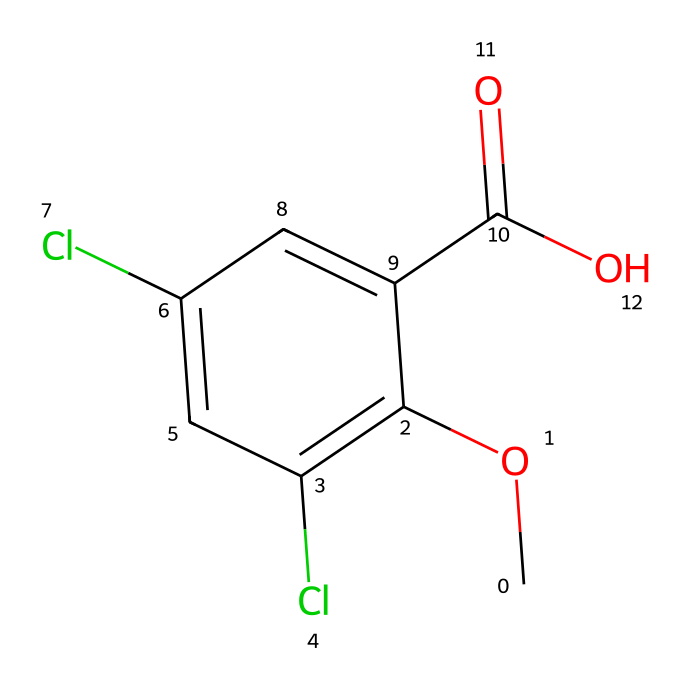What is the main functional group present in dicamba? The chemical has a carboxylic acid group, indicated by the -COOH moiety in its structure. This is typically represented by the "-C(=O)O" part in the SMILES notation.
Answer: carboxylic acid How many chlorine atoms are present in dicamba? By examining the structure, we see two chlorine atoms attached to the aromatic ring. In the SMILES, they are represented as "Cl" and appear twice.
Answer: 2 What is the primary use of dicamba? Dicamba is primarily used as a herbicide. Its purpose is to control broadleaf weeds and other unwanted vegetation in agricultural settings.
Answer: herbicide Which element in dicamba contributes to its electronegativity and stability? The presence of chlorine atoms increases the electronegativity of the molecule, which helps stabilize the overall structure by attracting electrons. Chlorine is known for having a high electronegativity.
Answer: chlorine What is the total number of carbon atoms in dicamba? The structure shows a total of seven carbon atoms, which can be counted from the aromatic and aliphatic parts of the molecule in the SMILES representation.
Answer: 7 How does the presence of the -COO group affect dicamba’s solubility? The carboxylic acid (-COOH) functional group enhances the solubility of dicamba in water compared to non-polar compounds, due to hydrogen bonding capabilities.
Answer: increases solubility 